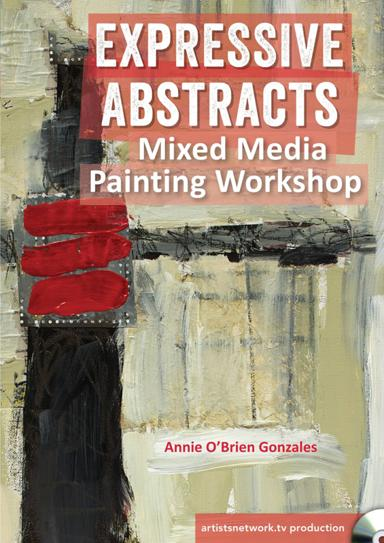Who is the artist conducting the painting workshop in the image? The painting workshop is conducted by Annie O'Brien Gonzales, an acclaimed artist noted for her vibrant and expressive approach to abstract painting. Attending this workshop offers a valuable opportunity to learn from her extensive experience and creative insights. 